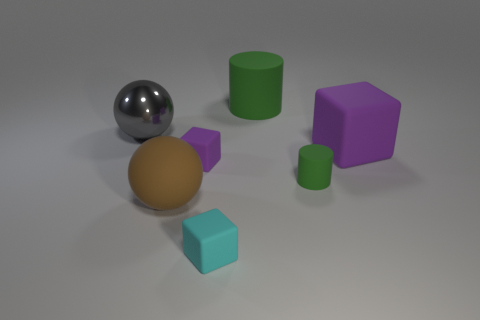Subtract all large matte cubes. How many cubes are left? 2 Subtract all brown cylinders. How many purple blocks are left? 2 Subtract 1 cubes. How many cubes are left? 2 Add 1 tiny things. How many objects exist? 8 Subtract all blue cubes. Subtract all cyan balls. How many cubes are left? 3 Subtract all balls. How many objects are left? 5 Add 5 tiny green matte things. How many tiny green matte things are left? 6 Add 5 big purple cubes. How many big purple cubes exist? 6 Subtract 0 blue cylinders. How many objects are left? 7 Subtract all big matte blocks. Subtract all brown rubber spheres. How many objects are left? 5 